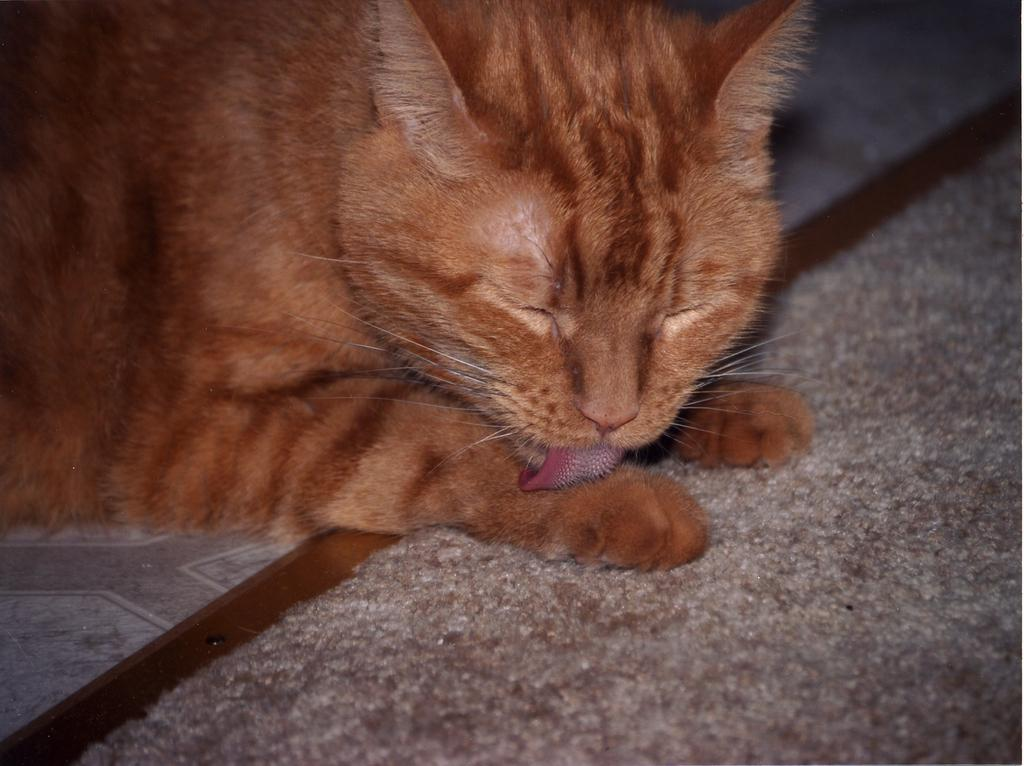What type of animal is in the image? There is a cat in the image. What is the color of the cat? The cat is brown in color. What facial features does the cat have? The cat has ears, eyes, a nose, and a tongue. What other features does the cat have? The cat has whiskers and legs. What type of authority does the cat have in the image? The image does not depict any authority figures or situations, and the cat is not shown in a position of authority. 